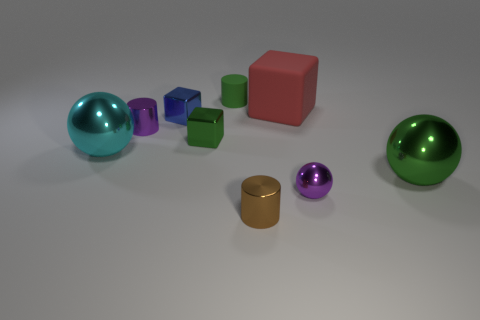How many purple things are the same shape as the large green thing?
Your answer should be very brief. 1. There is a blue block that is the same material as the brown cylinder; what is its size?
Your response must be concise. Small. Is the size of the purple cylinder the same as the purple ball?
Ensure brevity in your answer.  Yes. Are any tiny yellow cylinders visible?
Offer a terse response. No. There is a shiny block that is the same color as the small matte cylinder; what size is it?
Your answer should be compact. Small. There is a cube that is behind the blue shiny block in front of the matte thing that is right of the small brown metallic cylinder; what is its size?
Keep it short and to the point. Large. What number of other objects have the same material as the red object?
Ensure brevity in your answer.  1. How many cyan metallic things have the same size as the green metallic block?
Your answer should be compact. 0. What material is the cube that is on the right side of the cylinder that is behind the tiny metallic cylinder to the left of the brown metallic thing made of?
Your answer should be very brief. Rubber. What number of things are either cyan metal objects or small cyan rubber cylinders?
Your response must be concise. 1. 